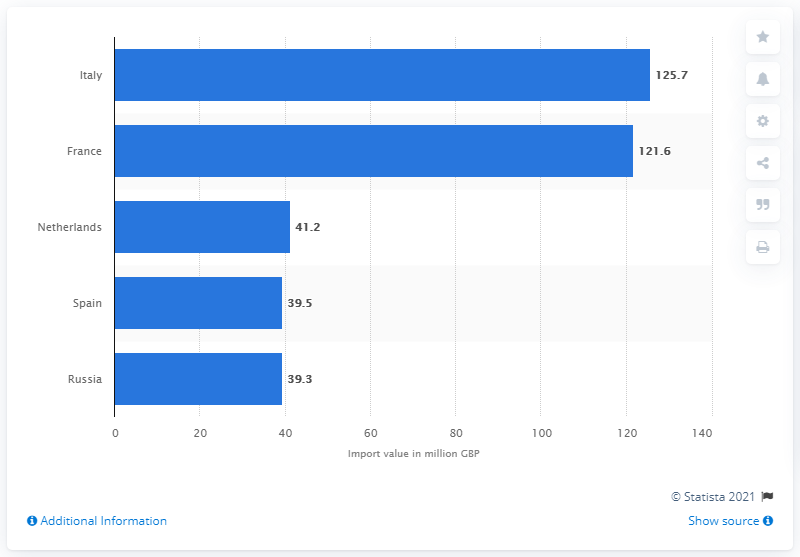Specify some key components in this picture. In 2020, France imported 121.6 pounds worth of spirits into the UK. In 2020, Italy was the leading country in spirits imports to the United Kingdom. In 2020, Italy imported a total of 125.7 pounds worth of spirits into the UK. 